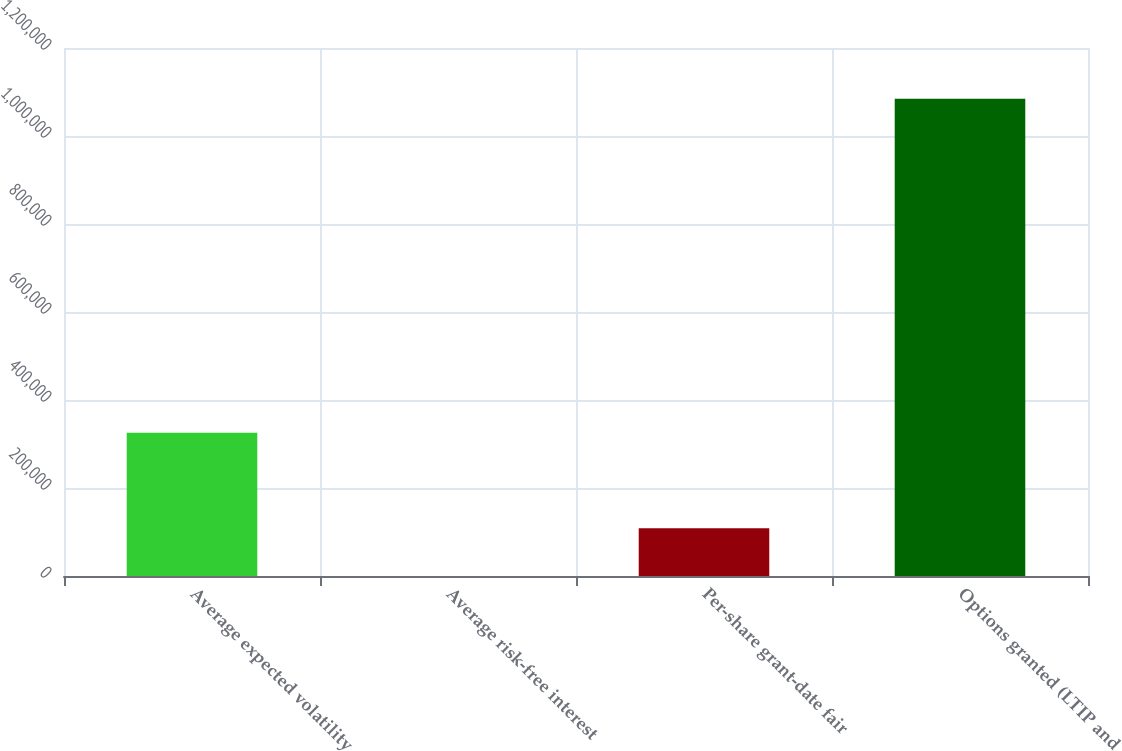Convert chart to OTSL. <chart><loc_0><loc_0><loc_500><loc_500><bar_chart><fcel>Average expected volatility<fcel>Average risk-free interest<fcel>Per-share grant-date fair<fcel>Options granted (LTIP and<nl><fcel>325413<fcel>3.63<fcel>108473<fcel>1.0847e+06<nl></chart> 